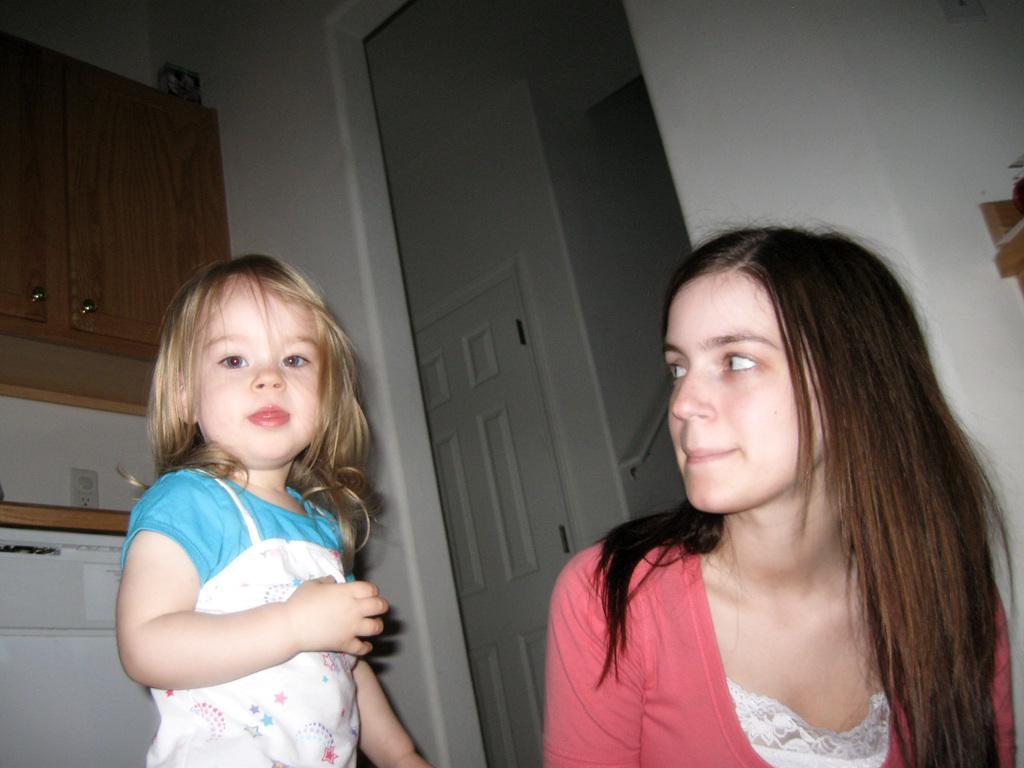How would you summarize this image in a sentence or two? In this image there is a small girl standing beside the lady, behind them there are wooden cupboards and door to access. 